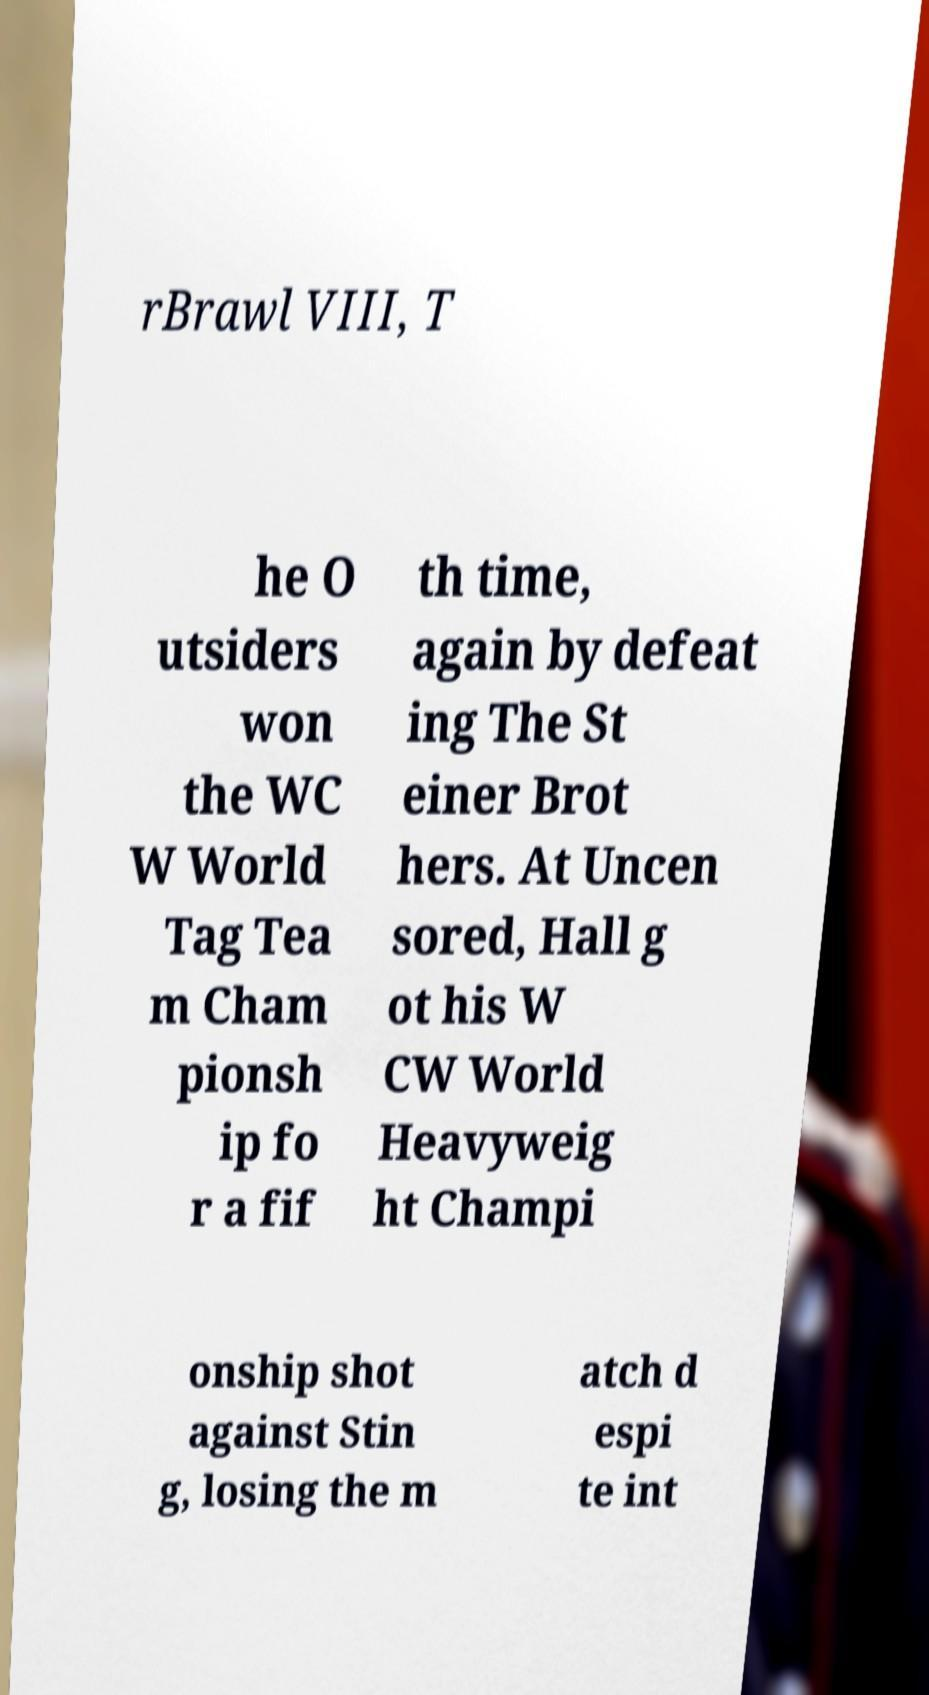Can you accurately transcribe the text from the provided image for me? rBrawl VIII, T he O utsiders won the WC W World Tag Tea m Cham pionsh ip fo r a fif th time, again by defeat ing The St einer Brot hers. At Uncen sored, Hall g ot his W CW World Heavyweig ht Champi onship shot against Stin g, losing the m atch d espi te int 